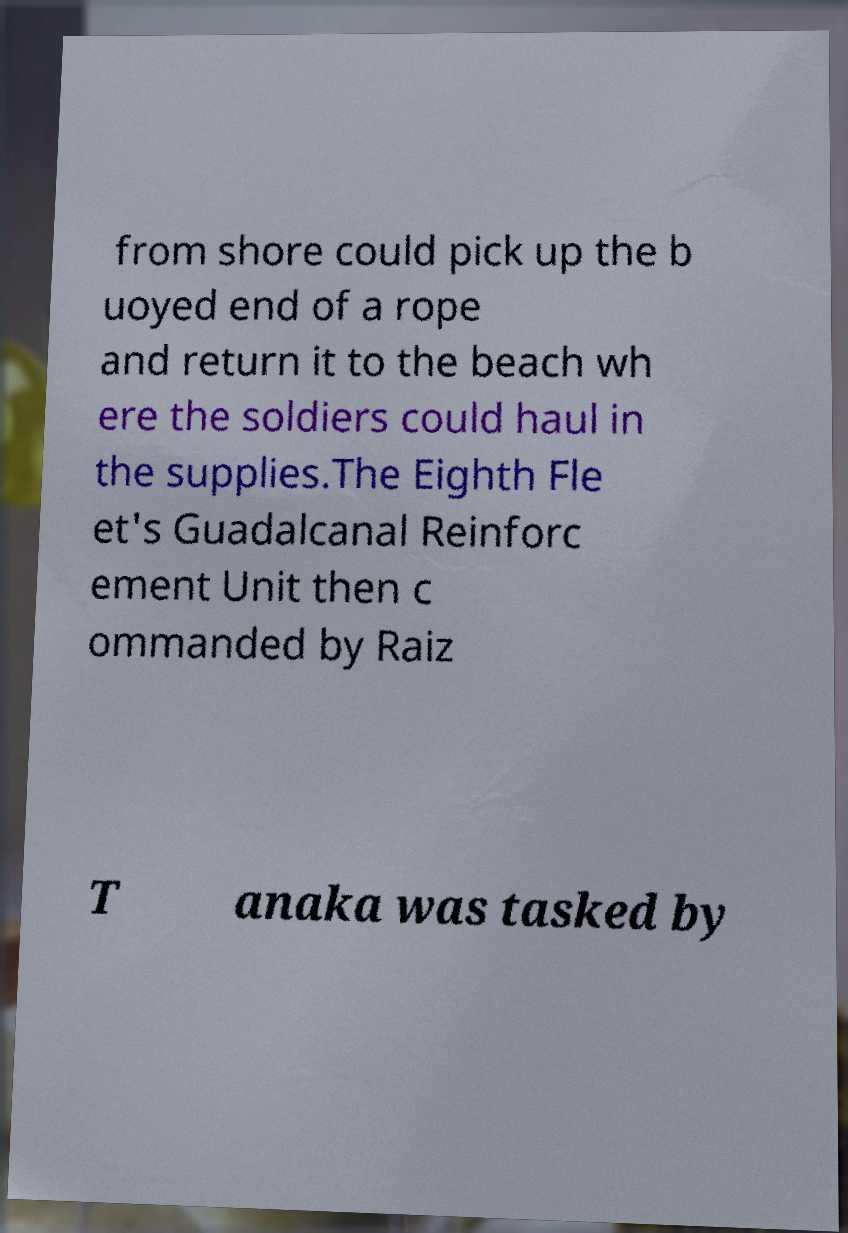There's text embedded in this image that I need extracted. Can you transcribe it verbatim? from shore could pick up the b uoyed end of a rope and return it to the beach wh ere the soldiers could haul in the supplies.The Eighth Fle et's Guadalcanal Reinforc ement Unit then c ommanded by Raiz T anaka was tasked by 